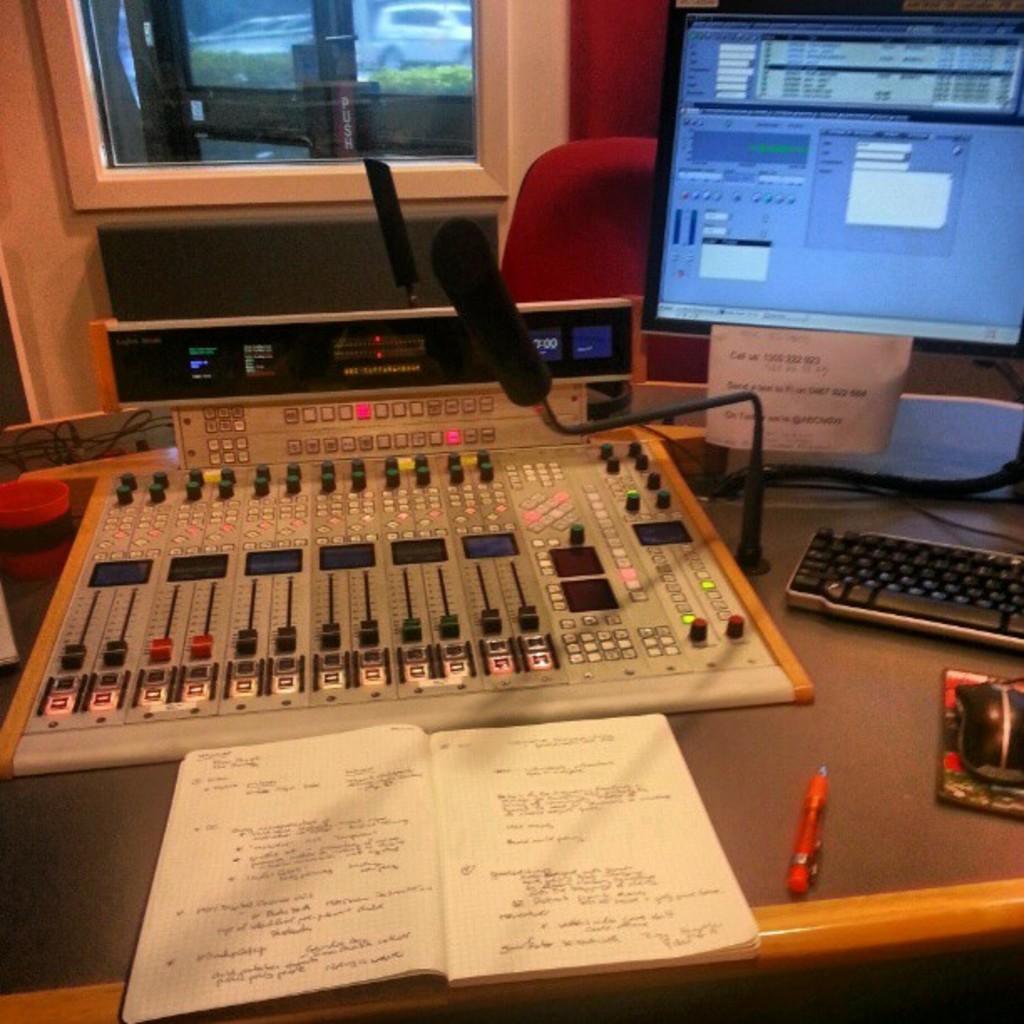Could you give a brief overview of what you see in this image? In this image I can see a table and on it I can see an equipment, a pen, a notebook, a mouse, a mouse pad, a keyboard, a mac, a monitor and a white colour paper. I can also see something is written on the notebook and on the paper. In the background I can see few wires, a red chair, a window and through the window I can see bushes and a car. 